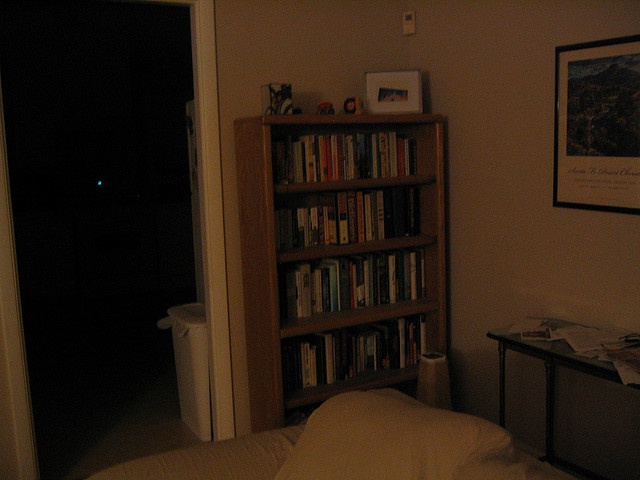Describe the objects in this image and their specific colors. I can see chair in black, maroon, and brown tones, couch in black, maroon, and brown tones, book in black and maroon tones, book in black, maroon, and gray tones, and book in black and maroon tones in this image. 